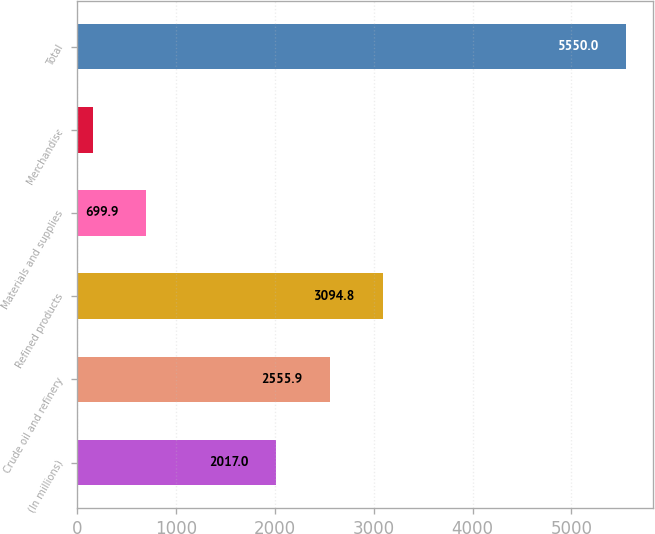Convert chart to OTSL. <chart><loc_0><loc_0><loc_500><loc_500><bar_chart><fcel>(In millions)<fcel>Crude oil and refinery<fcel>Refined products<fcel>Materials and supplies<fcel>Merchandise<fcel>Total<nl><fcel>2017<fcel>2555.9<fcel>3094.8<fcel>699.9<fcel>161<fcel>5550<nl></chart> 